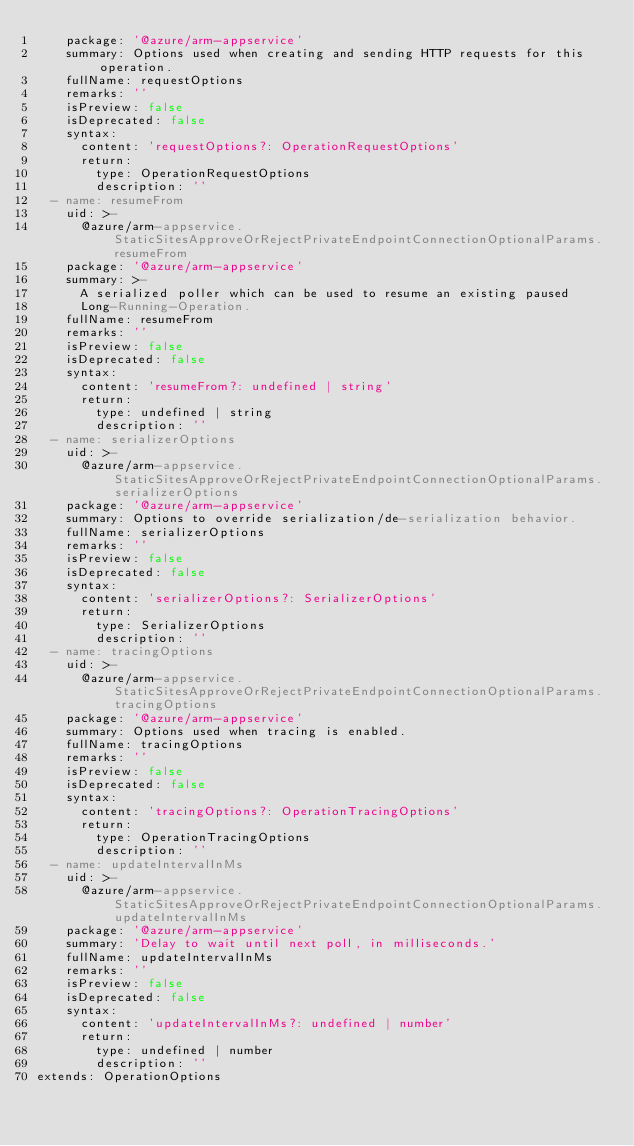<code> <loc_0><loc_0><loc_500><loc_500><_YAML_>    package: '@azure/arm-appservice'
    summary: Options used when creating and sending HTTP requests for this operation.
    fullName: requestOptions
    remarks: ''
    isPreview: false
    isDeprecated: false
    syntax:
      content: 'requestOptions?: OperationRequestOptions'
      return:
        type: OperationRequestOptions
        description: ''
  - name: resumeFrom
    uid: >-
      @azure/arm-appservice.StaticSitesApproveOrRejectPrivateEndpointConnectionOptionalParams.resumeFrom
    package: '@azure/arm-appservice'
    summary: >-
      A serialized poller which can be used to resume an existing paused
      Long-Running-Operation.
    fullName: resumeFrom
    remarks: ''
    isPreview: false
    isDeprecated: false
    syntax:
      content: 'resumeFrom?: undefined | string'
      return:
        type: undefined | string
        description: ''
  - name: serializerOptions
    uid: >-
      @azure/arm-appservice.StaticSitesApproveOrRejectPrivateEndpointConnectionOptionalParams.serializerOptions
    package: '@azure/arm-appservice'
    summary: Options to override serialization/de-serialization behavior.
    fullName: serializerOptions
    remarks: ''
    isPreview: false
    isDeprecated: false
    syntax:
      content: 'serializerOptions?: SerializerOptions'
      return:
        type: SerializerOptions
        description: ''
  - name: tracingOptions
    uid: >-
      @azure/arm-appservice.StaticSitesApproveOrRejectPrivateEndpointConnectionOptionalParams.tracingOptions
    package: '@azure/arm-appservice'
    summary: Options used when tracing is enabled.
    fullName: tracingOptions
    remarks: ''
    isPreview: false
    isDeprecated: false
    syntax:
      content: 'tracingOptions?: OperationTracingOptions'
      return:
        type: OperationTracingOptions
        description: ''
  - name: updateIntervalInMs
    uid: >-
      @azure/arm-appservice.StaticSitesApproveOrRejectPrivateEndpointConnectionOptionalParams.updateIntervalInMs
    package: '@azure/arm-appservice'
    summary: 'Delay to wait until next poll, in milliseconds.'
    fullName: updateIntervalInMs
    remarks: ''
    isPreview: false
    isDeprecated: false
    syntax:
      content: 'updateIntervalInMs?: undefined | number'
      return:
        type: undefined | number
        description: ''
extends: OperationOptions
</code> 